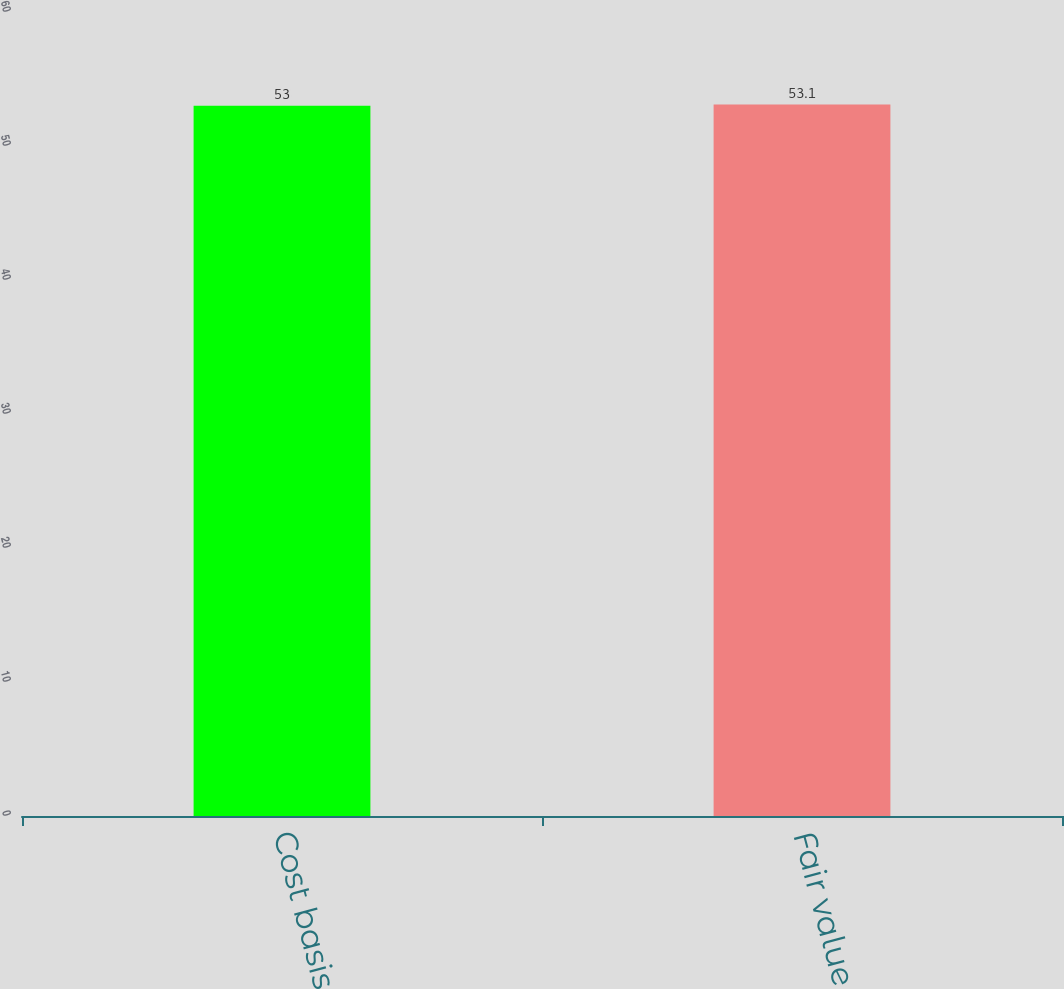Convert chart to OTSL. <chart><loc_0><loc_0><loc_500><loc_500><bar_chart><fcel>Cost basis<fcel>Fair value<nl><fcel>53<fcel>53.1<nl></chart> 